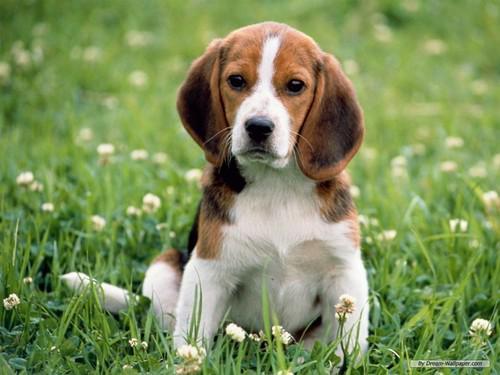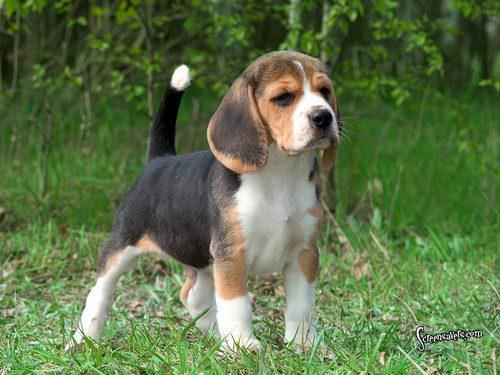The first image is the image on the left, the second image is the image on the right. Assess this claim about the two images: "There are no more than two animals". Correct or not? Answer yes or no. Yes. 